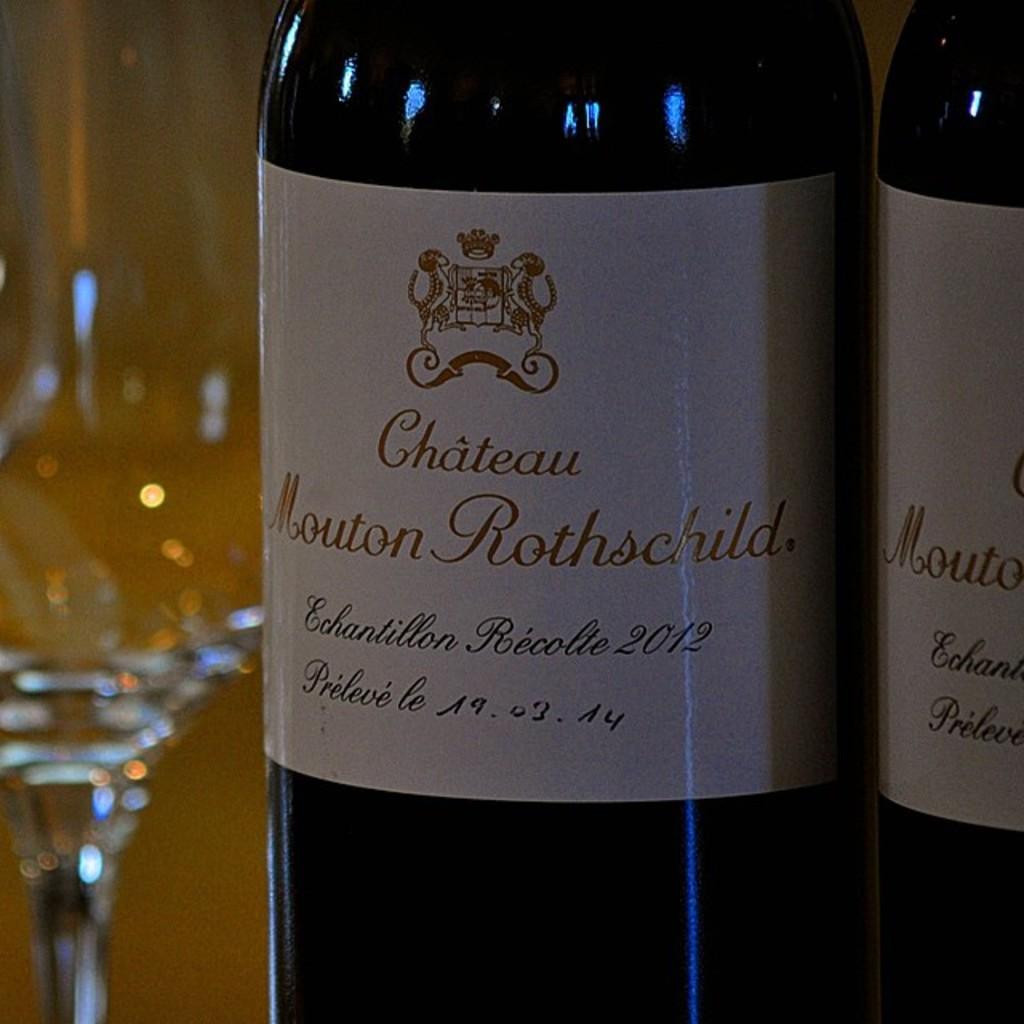What is in the bottle?
Make the answer very short. Chateau mouton rothschild. What year was this bottled?
Give a very brief answer. 2012. 